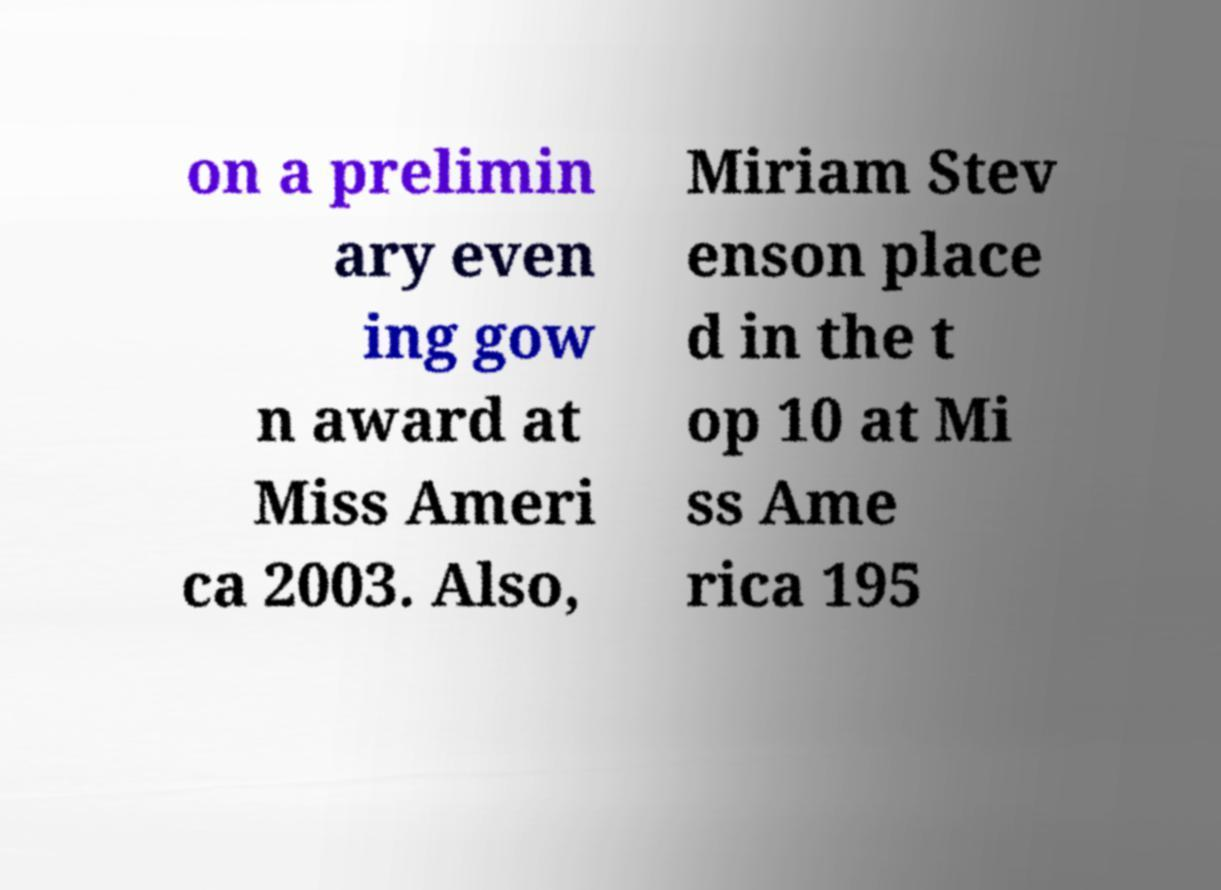For documentation purposes, I need the text within this image transcribed. Could you provide that? on a prelimin ary even ing gow n award at Miss Ameri ca 2003. Also, Miriam Stev enson place d in the t op 10 at Mi ss Ame rica 195 